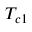Convert formula to latex. <formula><loc_0><loc_0><loc_500><loc_500>T _ { c 1 }</formula> 